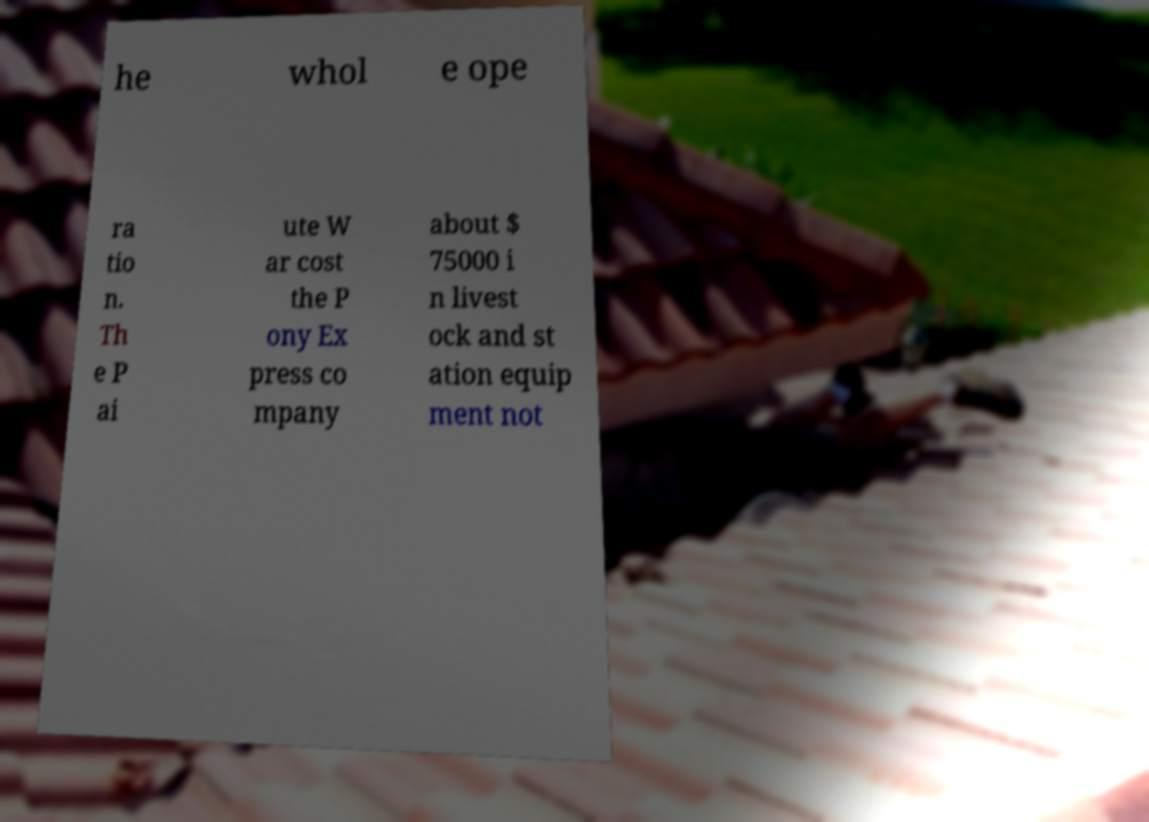Can you read and provide the text displayed in the image?This photo seems to have some interesting text. Can you extract and type it out for me? he whol e ope ra tio n. Th e P ai ute W ar cost the P ony Ex press co mpany about $ 75000 i n livest ock and st ation equip ment not 